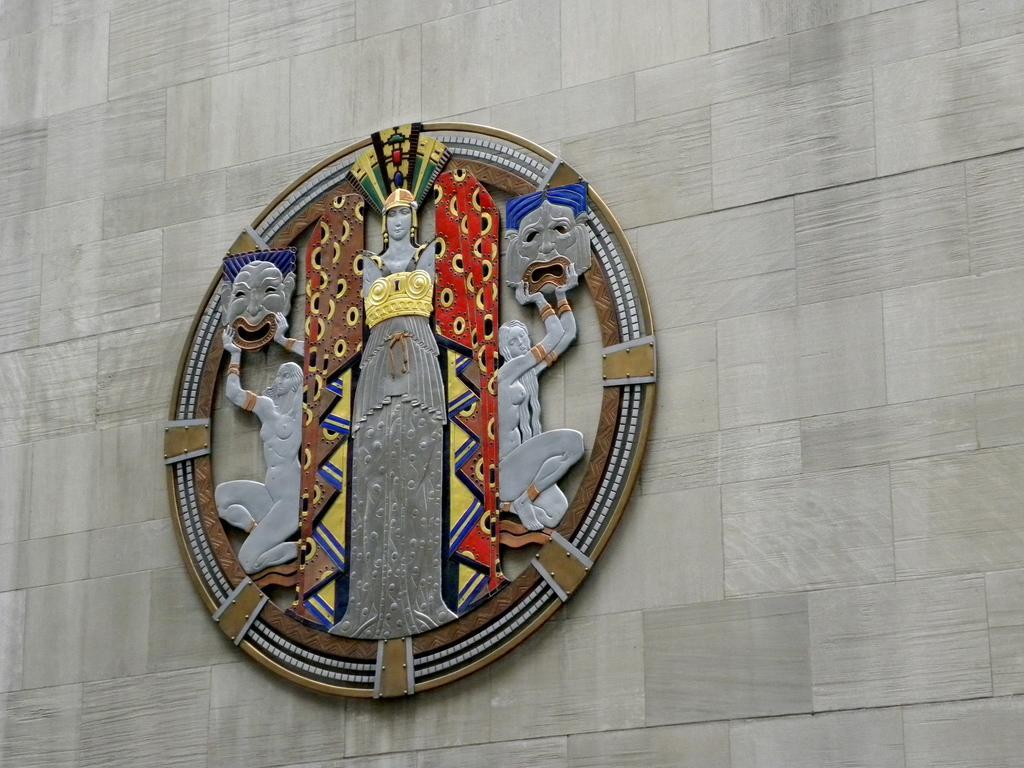Could you give a brief overview of what you see in this image? In this image in the background there is a wall, on the wall there is one board. 